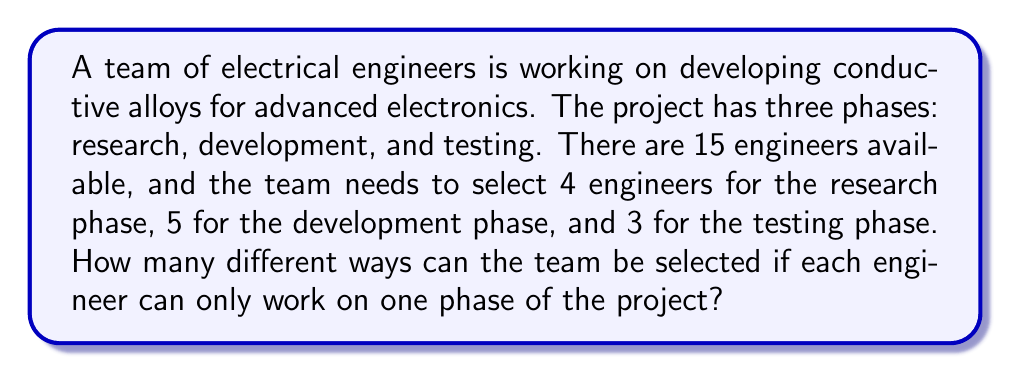Give your solution to this math problem. To solve this problem, we need to use the multiplication principle of counting and the concept of combinations. Let's break it down step by step:

1. For the research phase, we need to select 4 engineers out of 15. This can be done in $\binom{15}{4}$ ways.

2. After selecting the research team, we have 11 engineers left. From these, we need to select 5 for the development phase. This can be done in $\binom{11}{5}$ ways.

3. Finally, we have 6 engineers left, from which we need to select 3 for the testing phase. This can be done in $\binom{6}{3}$ ways.

4. Since these selections are independent and must all occur, we multiply the number of ways for each phase:

   $$\text{Total number of ways} = \binom{15}{4} \times \binom{11}{5} \times \binom{6}{3}$$

5. Now, let's calculate each combination:

   $\binom{15}{4} = \frac{15!}{4!(15-4)!} = \frac{15!}{4!11!} = 1365$

   $\binom{11}{5} = \frac{11!}{5!(11-5)!} = \frac{11!}{5!6!} = 462$

   $\binom{6}{3} = \frac{6!}{3!(6-3)!} = \frac{6!}{3!3!} = 20$

6. Multiply these results:

   $1365 \times 462 \times 20 = 12,617,400$

Therefore, there are 12,617,400 different ways to select the team for the three project phases.
Answer: 12,617,400 